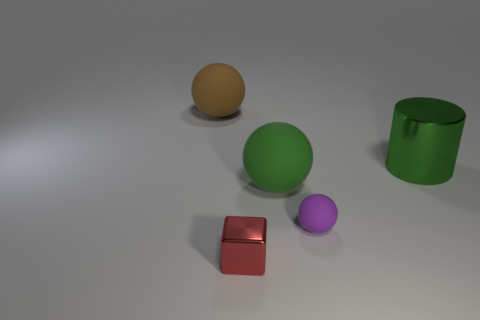Is there anything else that has the same shape as the red shiny object?
Your answer should be compact. No. Does the large rubber object that is right of the tiny metallic block have the same color as the big shiny object?
Offer a very short reply. Yes. How big is the thing that is left of the large green rubber object and to the right of the brown matte thing?
Keep it short and to the point. Small. How many other objects are the same material as the cylinder?
Make the answer very short. 1. There is a metal object in front of the large green metal object; how big is it?
Provide a succinct answer. Small. What number of big objects are green shiny cylinders or green rubber things?
Your response must be concise. 2. Are there any other things that have the same color as the big metallic object?
Provide a succinct answer. Yes. There is a tiny purple rubber sphere; are there any small red objects right of it?
Provide a short and direct response. No. There is a matte object behind the large ball that is in front of the brown matte sphere; what is its size?
Make the answer very short. Large. Is the number of red cubes that are behind the small purple thing the same as the number of spheres in front of the green matte thing?
Ensure brevity in your answer.  No. 